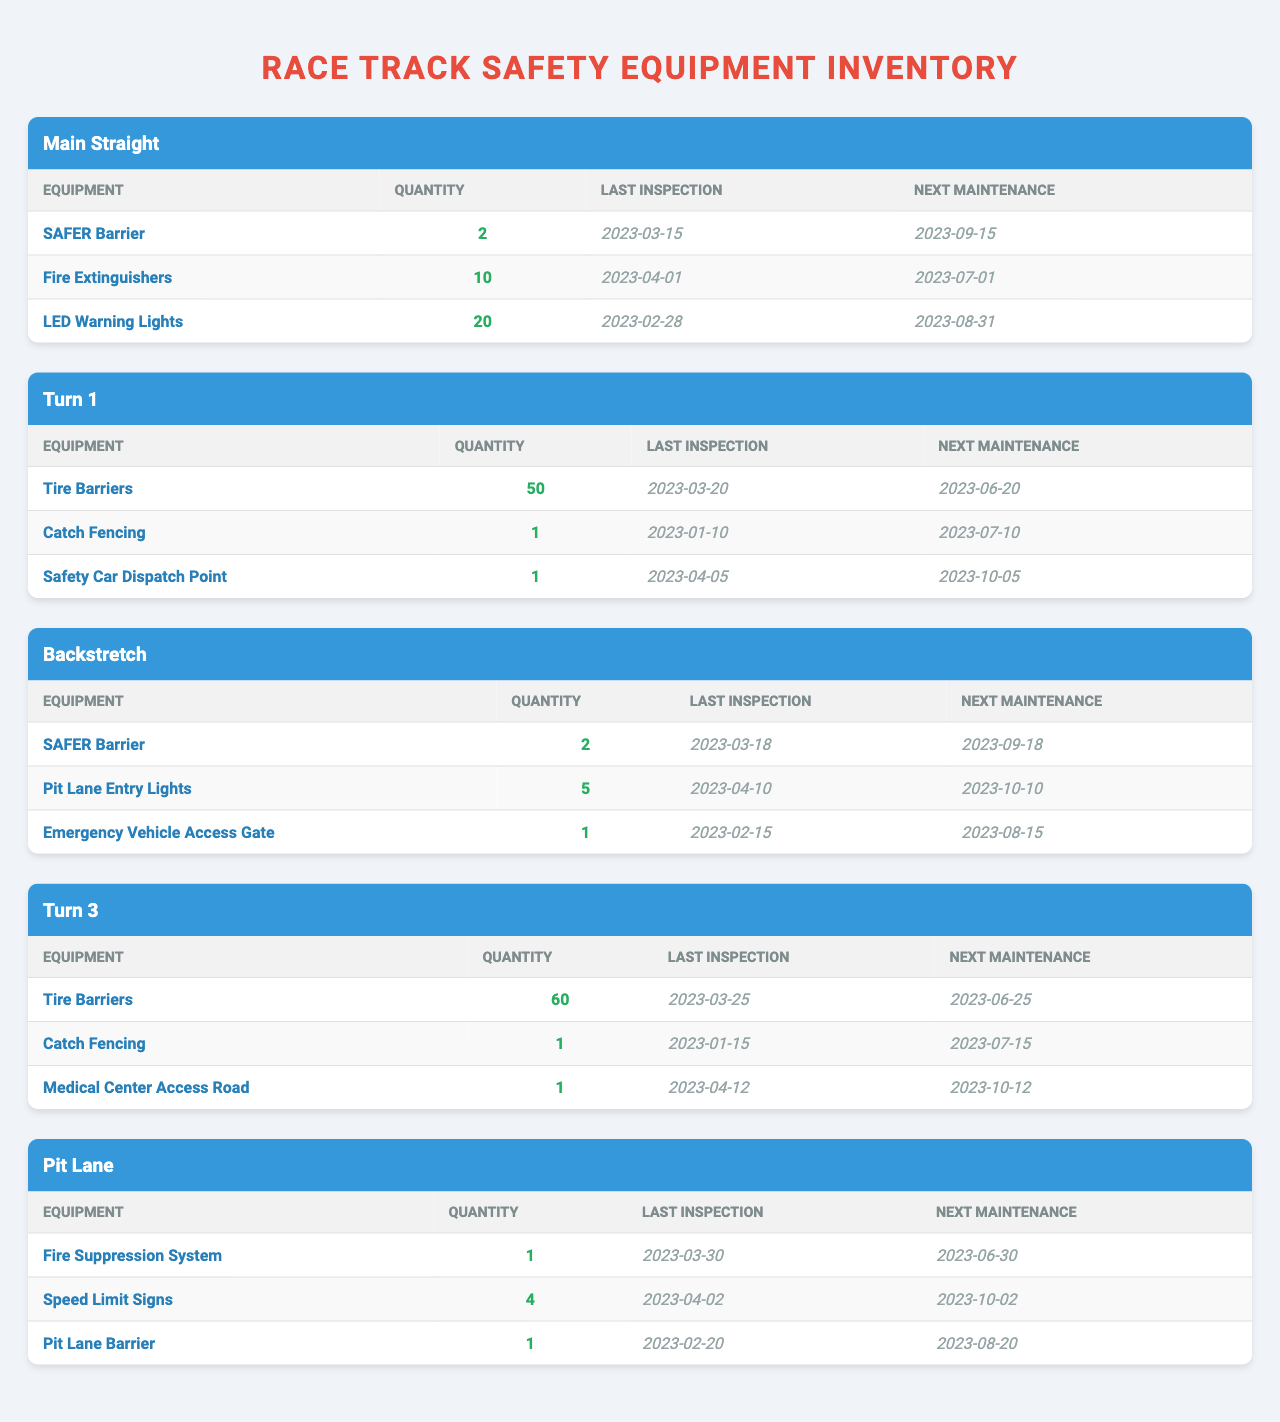What is the quantity of Fire Extinguishers in the Main Straight? In the Main Straight section, the table lists the Fire Extinguishers with a quantity of 10.
Answer: 10 When is the next maintenance scheduled for the Tire Barriers in Turn 1? The Tire Barriers in Turn 1 are listed with a next maintenance date of 2023-06-20.
Answer: 2023-06-20 How many Emergency Vehicle Access Gates are present in the Backstretch? The Backstretch section indicates the presence of 1 Emergency Vehicle Access Gate.
Answer: 1 Which track section has the highest quantity of Tire Barriers? Turn 3 has 60 Tire Barriers, which is the highest quantity compared to 50 in Turn 1.
Answer: Turn 3 What is the time interval between the Last Inspection and Next Maintenance for the SAFER Barrier in the Main Straight? The Last Inspection for the SAFER Barrier in the Main Straight was on 2023-03-15 with the Next Maintenance on 2023-09-15. This is a 6-month interval.
Answer: 6 months Are there any equipment items in the Pit Lane that have their next maintenance scheduled before July 2023? The Fire Suppression System and the Speed Limit Signs in the Pit Lane have their next maintenance scheduled for June 30 and October 2, respectively. Only the Fire Suppression System is before July 2023.
Answer: Yes How many total Fire Extinguishers are listed across all track sections? The Main Straight has 10 Fire Extinguishers. The other sections do not report any Fire Extinguishers. Therefore, the total quantity is 10.
Answer: 10 Which track section's safety equipment has the earliest next maintenance date? Looking at the next maintenance dates, the earliest is for the Fire Extinguishers in the Main Straight, due on 2023-07-01.
Answer: Main Straight What is the average quantity of safety equipment across all sections listed in the table? Summing the quantities: 2 (Main Straight) + 10 + 20 + 50 + 1 + 1 + 60 + 1 + 1 + 4 + 1 = 152. There are 11 equipment entries across sections, hence the average is 152/11 ≈ 13.82.
Answer: Approximately 13.82 How many sections have Catch Fencing listed as safety equipment? Catch Fencing appears in Turn 1 and Turn 3, which totals to 2 sections.
Answer: 2 